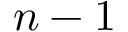<formula> <loc_0><loc_0><loc_500><loc_500>n - 1</formula> 